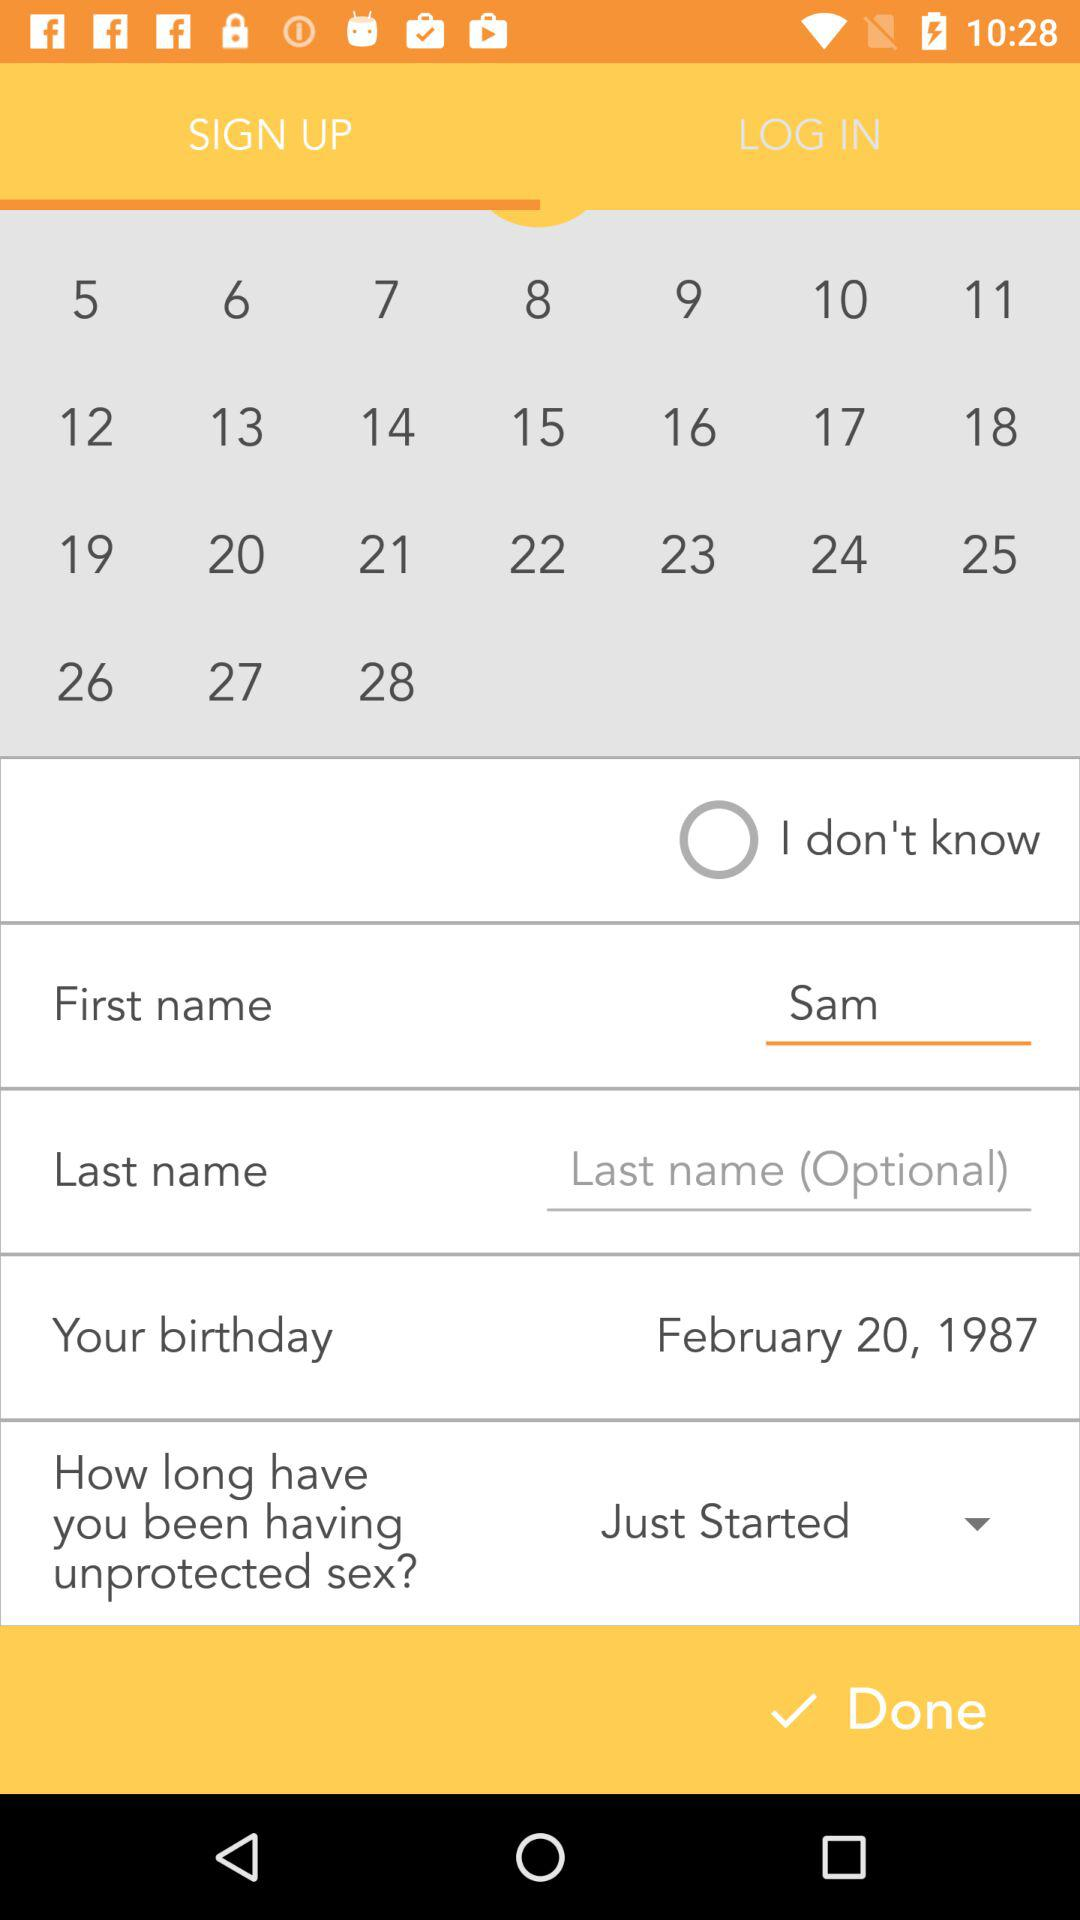Which tab is selected? The selected tab is "SIGN UP". 